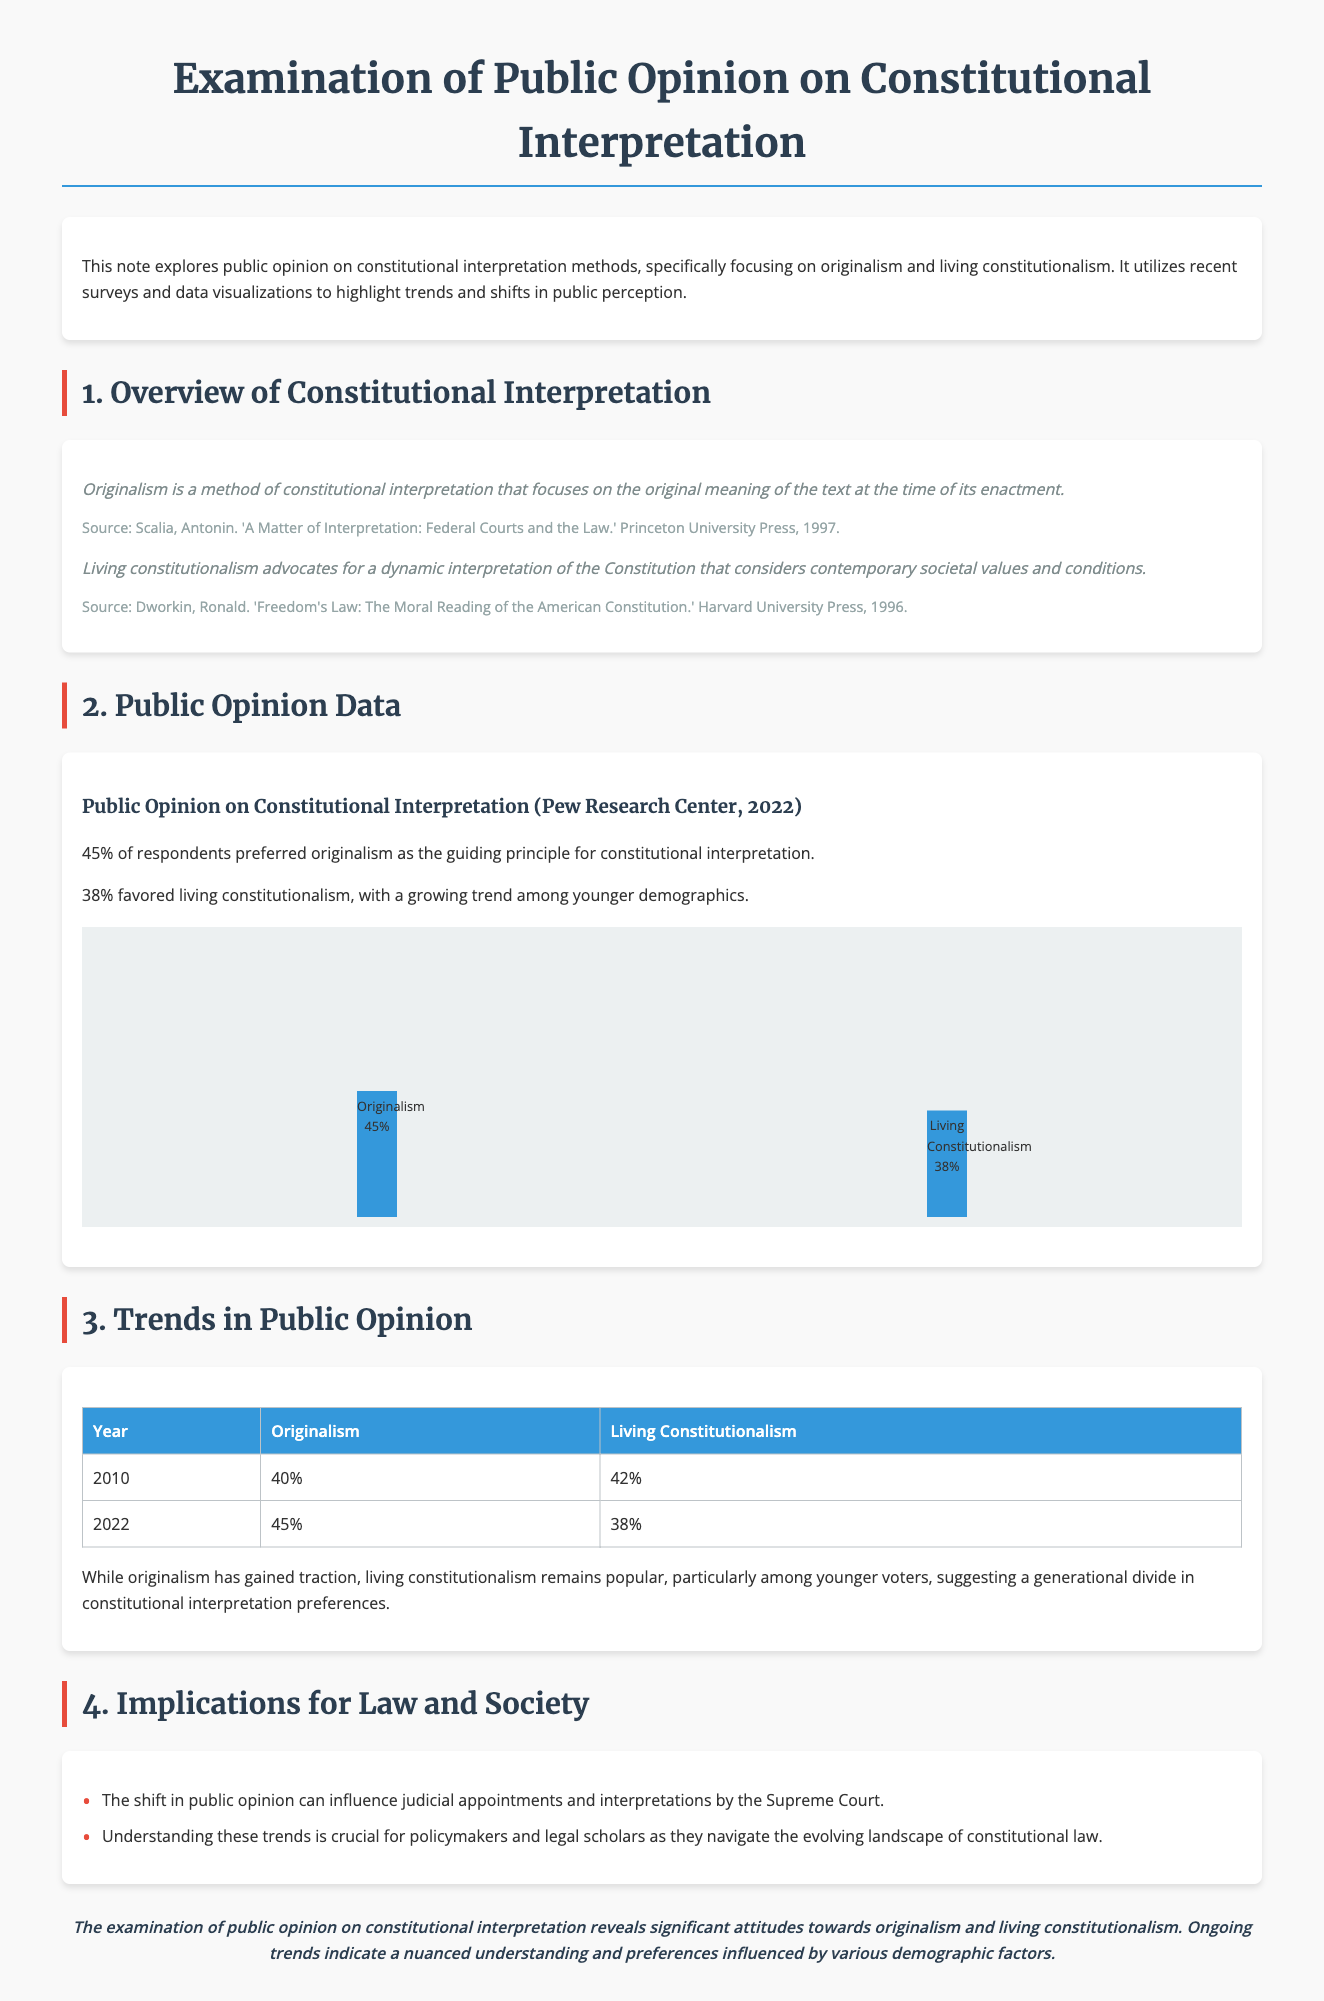what percentage of respondents preferred originalism? The document states that 45% of respondents preferred originalism as the guiding principle for constitutional interpretation.
Answer: 45% what percentage favored living constitutionalism? According to the document, 38% favored living constitutionalism.
Answer: 38% in what year did originalism have a 40% preference? The table in the document indicates that originalism had a 40% preference in the year 2010.
Answer: 2010 what is the trend of originalism's preference from 2010 to 2022? The document shows that originalism increased from 40% in 2010 to 45% in 2022, indicating a rise in preference.
Answer: Increased which demographic shows a growing trend towards living constitutionalism? The document mentions that the growing trend of living constitutionalism is particularly among younger demographics.
Answer: Younger demographics what are the implications of the shift in public opinion? The document lists implications indicating that this shift can influence judicial appointments and interpretations by the Supreme Court.
Answer: Judicial appointments what does living constitutionalism consider for interpretation? The document states that living constitutionalism considers contemporary societal values and conditions for interpretation.
Answer: Contemporary societal values what was originalism's percentage in 2010? The document specifies that originalism's percentage in 2010 was 40%.
Answer: 40% what source is cited for the definition of originalism? The document cites Antonin Scalia's book as the source for the definition of originalism.
Answer: Antonin Scalia's book 